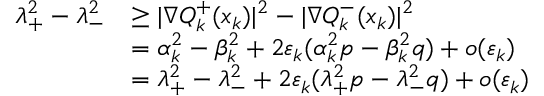<formula> <loc_0><loc_0><loc_500><loc_500>\begin{array} { r l } { \lambda _ { + } ^ { 2 } - \lambda _ { - } ^ { 2 } } & { \geq | \nabla Q _ { k } ^ { + } ( x _ { k } ) | ^ { 2 } - | \nabla Q _ { k } ^ { - } ( x _ { k } ) | ^ { 2 } } \\ & { = \alpha _ { k } ^ { 2 } - \beta _ { k } ^ { 2 } + 2 \varepsilon _ { k } ( \alpha _ { k } ^ { 2 } p - \beta _ { k } ^ { 2 } q ) + o ( \varepsilon _ { k } ) } \\ & { = \lambda _ { + } ^ { 2 } - \lambda _ { - } ^ { 2 } + 2 \varepsilon _ { k } ( \lambda _ { + } ^ { 2 } p - \lambda _ { - } ^ { 2 } q ) + o ( \varepsilon _ { k } ) } \end{array}</formula> 